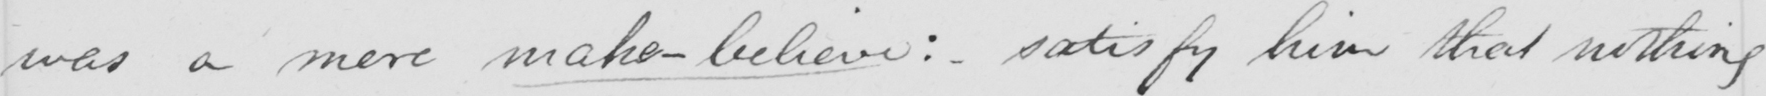What text is written in this handwritten line? was a mere make-believe: satisfy him that nothing 